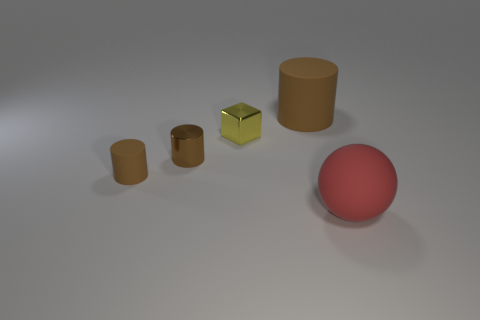How many brown cylinders must be subtracted to get 1 brown cylinders? 2 Subtract all shiny cylinders. How many cylinders are left? 2 Add 4 large red things. How many objects exist? 9 Subtract all cylinders. How many objects are left? 2 Subtract 1 blocks. How many blocks are left? 0 Subtract all yellow cylinders. How many brown cubes are left? 0 Add 4 tiny metal cylinders. How many tiny metal cylinders exist? 5 Subtract 0 yellow cylinders. How many objects are left? 5 Subtract all cyan cylinders. Subtract all green balls. How many cylinders are left? 3 Subtract all small blue balls. Subtract all small yellow things. How many objects are left? 4 